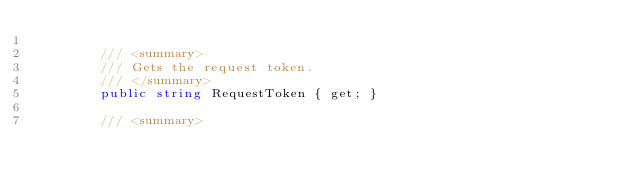<code> <loc_0><loc_0><loc_500><loc_500><_C#_>
        /// <summary>
        /// Gets the request token.
        /// </summary>
        public string RequestToken { get; }

        /// <summary></code> 